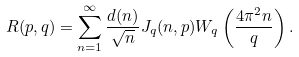Convert formula to latex. <formula><loc_0><loc_0><loc_500><loc_500>R ( p , q ) = \sum _ { n = 1 } ^ { \infty } \frac { d ( n ) } { \sqrt { n } } J _ { q } ( n , p ) W _ { q } \left ( \frac { 4 \pi ^ { 2 } n } { q } \right ) .</formula> 